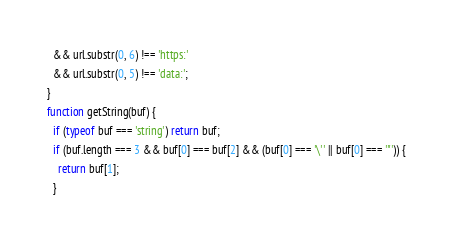Convert code to text. <code><loc_0><loc_0><loc_500><loc_500><_JavaScript_>  && url.substr(0, 6) !== 'https:'
  && url.substr(0, 5) !== 'data:';
}
function getString(buf) {
  if (typeof buf === 'string') return buf;
  if (buf.length === 3 && buf[0] === buf[2] && (buf[0] === '\'' || buf[0] === '"')) {
    return buf[1];
  }</code> 